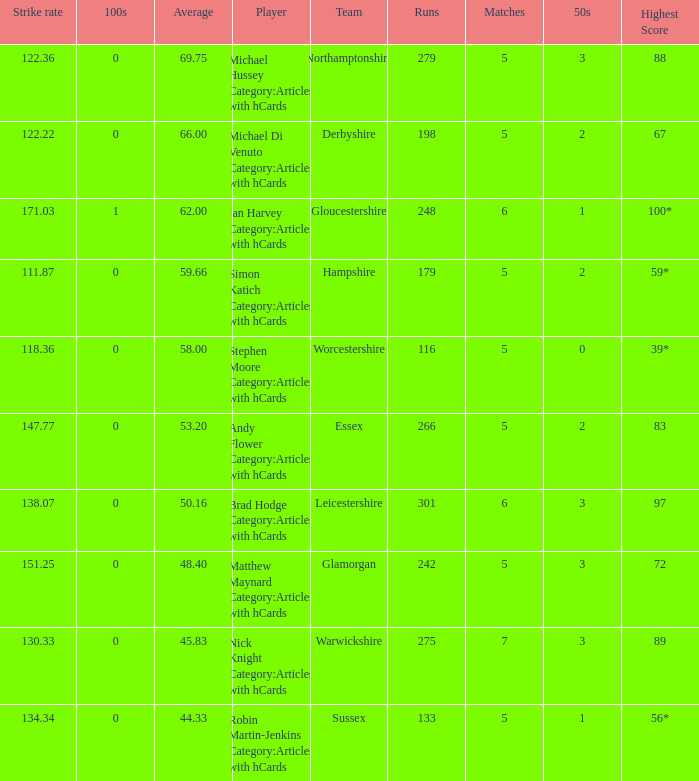Could you help me parse every detail presented in this table? {'header': ['Strike rate', '100s', 'Average', 'Player', 'Team', 'Runs', 'Matches', '50s', 'Highest Score'], 'rows': [['122.36', '0', '69.75', 'Michael Hussey Category:Articles with hCards', 'Northamptonshire', '279', '5', '3', '88'], ['122.22', '0', '66.00', 'Michael Di Venuto Category:Articles with hCards', 'Derbyshire', '198', '5', '2', '67'], ['171.03', '1', '62.00', 'Ian Harvey Category:Articles with hCards', 'Gloucestershire', '248', '6', '1', '100*'], ['111.87', '0', '59.66', 'Simon Katich Category:Articles with hCards', 'Hampshire', '179', '5', '2', '59*'], ['118.36', '0', '58.00', 'Stephen Moore Category:Articles with hCards', 'Worcestershire', '116', '5', '0', '39*'], ['147.77', '0', '53.20', 'Andy Flower Category:Articles with hCards', 'Essex', '266', '5', '2', '83'], ['138.07', '0', '50.16', 'Brad Hodge Category:Articles with hCards', 'Leicestershire', '301', '6', '3', '97'], ['151.25', '0', '48.40', 'Matthew Maynard Category:Articles with hCards', 'Glamorgan', '242', '5', '3', '72'], ['130.33', '0', '45.83', 'Nick Knight Category:Articles with hCards', 'Warwickshire', '275', '7', '3', '89'], ['134.34', '0', '44.33', 'Robin Martin-Jenkins Category:Articles with hCards', 'Sussex', '133', '5', '1', '56*']]} If the team is Worcestershire and the Matched had were 5, what is the highest score? 39*. 